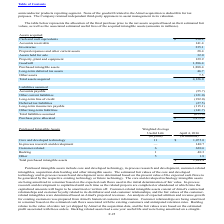According to Microchip Technology's financial document, What did purchased intangible assets include? core and developed technology, in-process research and development, customer-related intangibles, acquisition-date backlog and other intangible assets.. The document states: "Purchased intangible assets include core and developed technology, in-process research and development, customer-related intangibles, acquisition-date..." Also, How was the stimated fair values of the core and developed technology and in-process research and development determined? based on the present value of the expected cash flows to be generated by the respective existing technology or future technology.. The document states: "n-process research and development were determined based on the present value of the expected cash flows to be generated by the respective existing te..." Also, What was the amount of core and developed technology? According to the financial document, 1,075.0 (in millions). The relevant text states: "Core and developed technology 11 $ 1,075.0..." Also, can you calculate: What was the difference in Weighted Average Useful Life between Core and developed technology and customer-related assets? Based on the calculation: 11-6, the result is 5. This is based on the information: "Long-term income tax payable (115.1) Customer-related 6 630.6..." The key data points involved are: 11, 6. Also, can you calculate: What was the sum of the amount of Core and developed technology and in-process research and development assets? Based on the calculation: 1,075.0+140.7, the result is 1215.7 (in millions). This is based on the information: "In-process research and development — 140.7 Core and developed technology 11 $ 1,075.0..." The key data points involved are: 1,075.0, 140.7. Also, can you calculate: What was the Core and developed technology assets as a percentage of Total purchased intangible assets? Based on the calculation: 1,075.0/1,888.4, the result is 56.93 (percentage). This is based on the information: "Purchased intangible assets 1,888.4 Core and developed technology 11 $ 1,075.0..." The key data points involved are: 1,075.0, 1,888.4. 